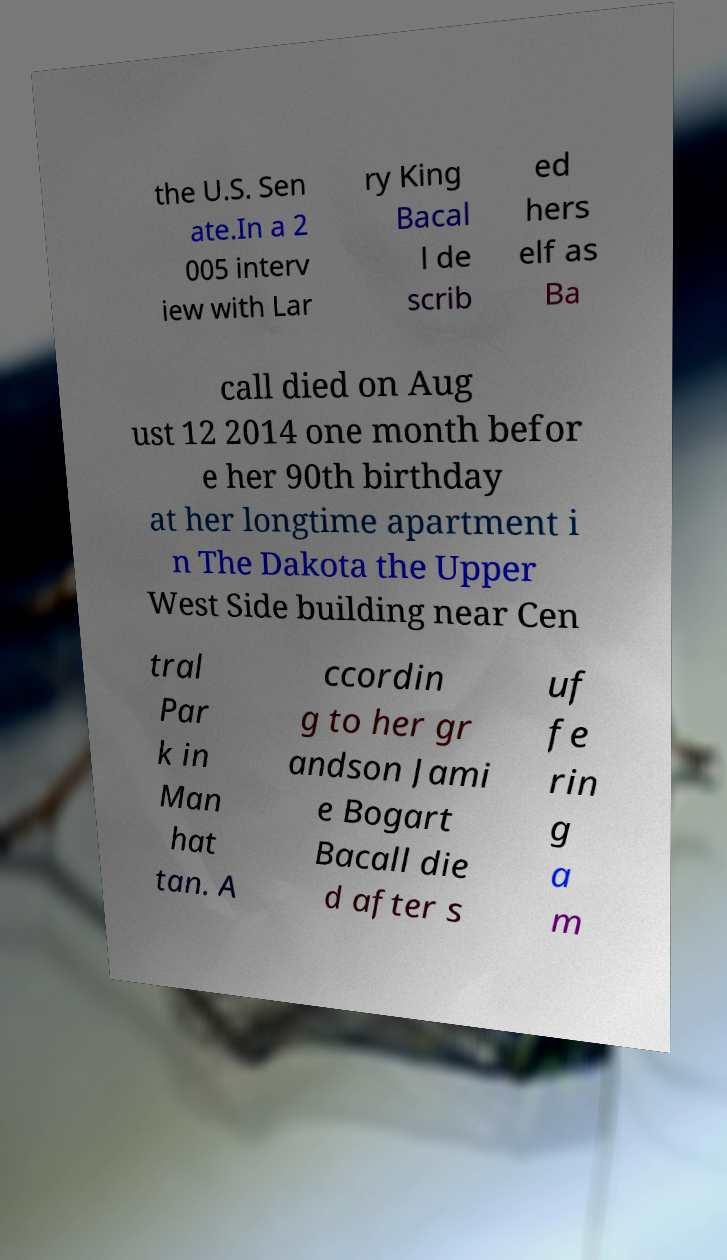Could you extract and type out the text from this image? the U.S. Sen ate.In a 2 005 interv iew with Lar ry King Bacal l de scrib ed hers elf as Ba call died on Aug ust 12 2014 one month befor e her 90th birthday at her longtime apartment i n The Dakota the Upper West Side building near Cen tral Par k in Man hat tan. A ccordin g to her gr andson Jami e Bogart Bacall die d after s uf fe rin g a m 